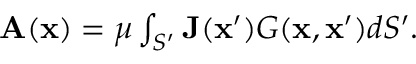<formula> <loc_0><loc_0><loc_500><loc_500>\begin{array} { r } { A ( x ) = \mu \int _ { S ^ { \prime } } J ( x ^ { \prime } ) G ( x , x ^ { \prime } ) d S ^ { \prime } . } \end{array}</formula> 